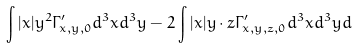<formula> <loc_0><loc_0><loc_500><loc_500>\int | x | y ^ { 2 } \Gamma _ { x , y , 0 } ^ { \prime } d ^ { 3 } x d ^ { 3 } y - 2 \int | x | y \cdot z \Gamma _ { x , y , z , 0 } ^ { \prime } d ^ { 3 } x d ^ { 3 } y d</formula> 